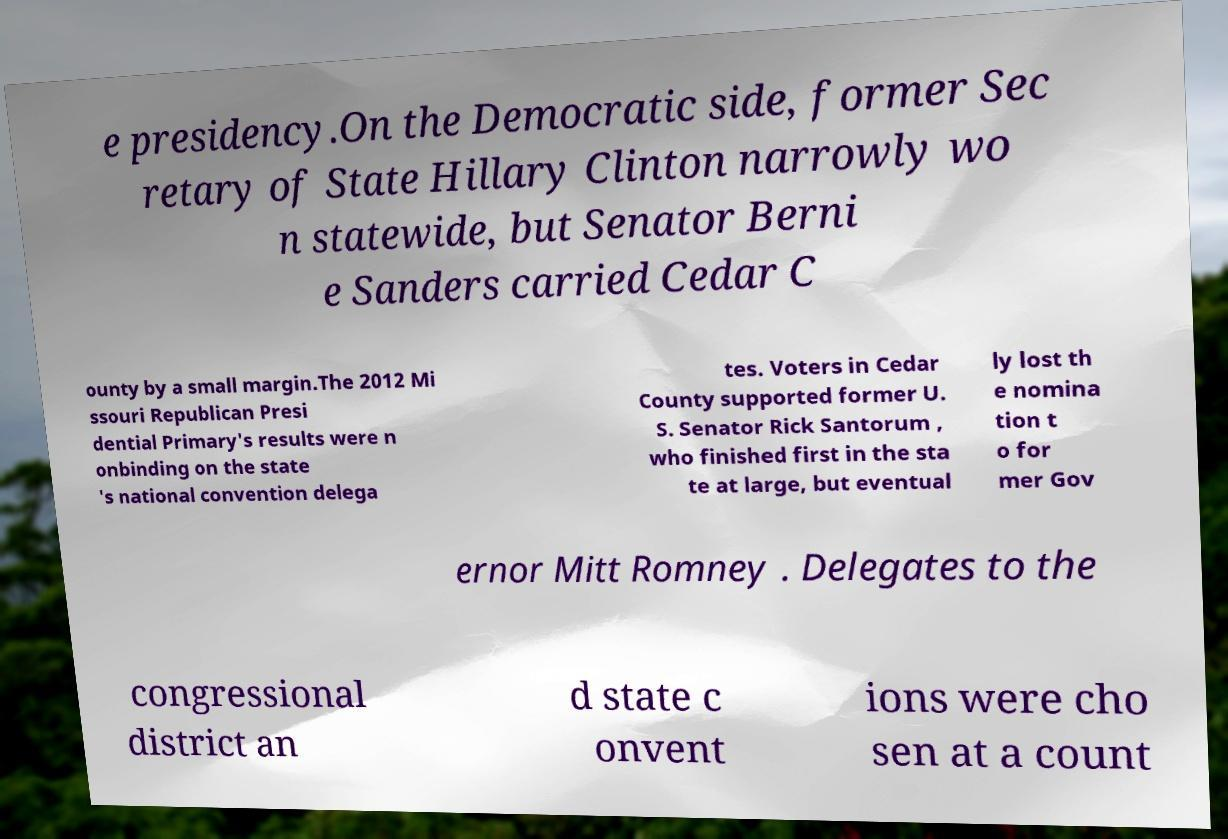What messages or text are displayed in this image? I need them in a readable, typed format. e presidency.On the Democratic side, former Sec retary of State Hillary Clinton narrowly wo n statewide, but Senator Berni e Sanders carried Cedar C ounty by a small margin.The 2012 Mi ssouri Republican Presi dential Primary's results were n onbinding on the state 's national convention delega tes. Voters in Cedar County supported former U. S. Senator Rick Santorum , who finished first in the sta te at large, but eventual ly lost th e nomina tion t o for mer Gov ernor Mitt Romney . Delegates to the congressional district an d state c onvent ions were cho sen at a count 